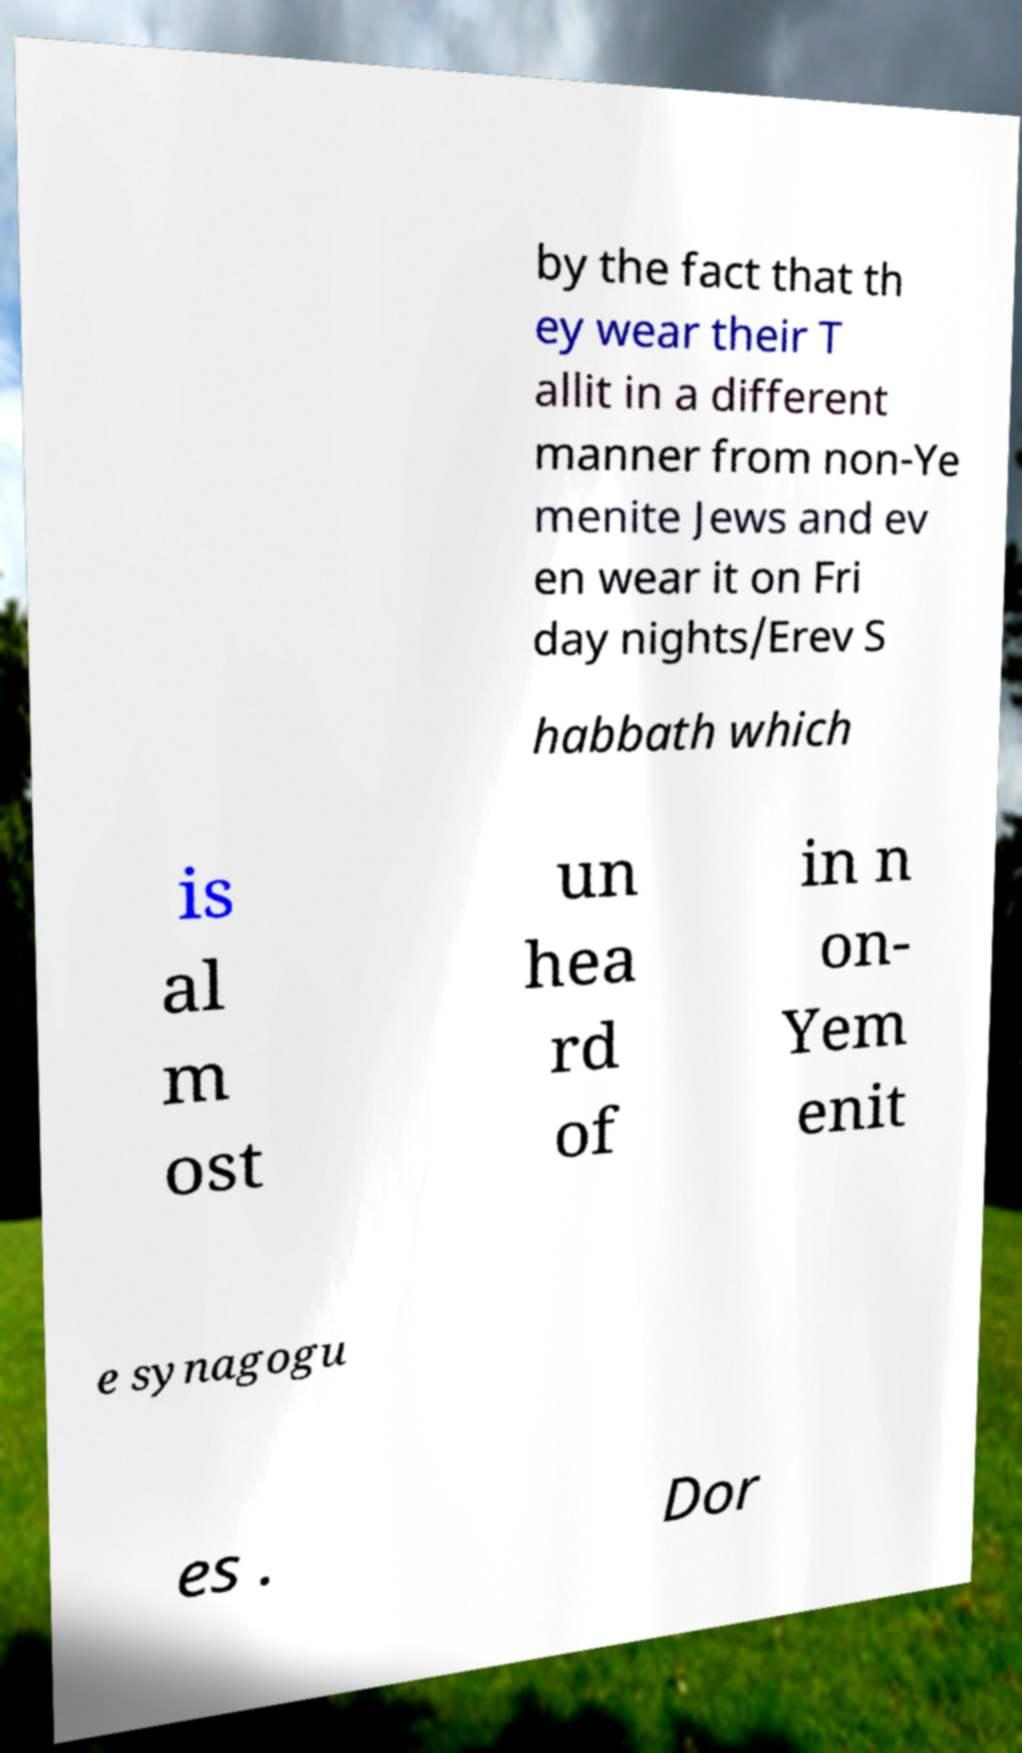Please read and relay the text visible in this image. What does it say? by the fact that th ey wear their T allit in a different manner from non-Ye menite Jews and ev en wear it on Fri day nights/Erev S habbath which is al m ost un hea rd of in n on- Yem enit e synagogu es . Dor 